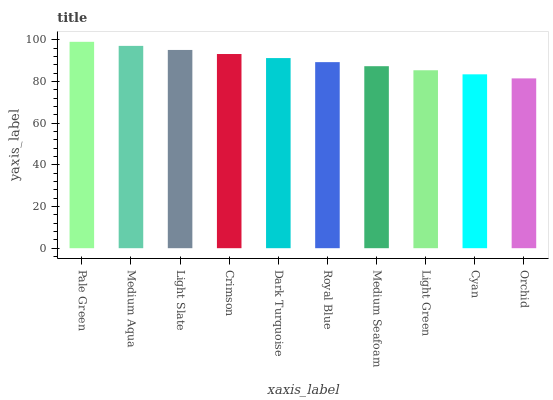Is Orchid the minimum?
Answer yes or no. Yes. Is Pale Green the maximum?
Answer yes or no. Yes. Is Medium Aqua the minimum?
Answer yes or no. No. Is Medium Aqua the maximum?
Answer yes or no. No. Is Pale Green greater than Medium Aqua?
Answer yes or no. Yes. Is Medium Aqua less than Pale Green?
Answer yes or no. Yes. Is Medium Aqua greater than Pale Green?
Answer yes or no. No. Is Pale Green less than Medium Aqua?
Answer yes or no. No. Is Dark Turquoise the high median?
Answer yes or no. Yes. Is Royal Blue the low median?
Answer yes or no. Yes. Is Orchid the high median?
Answer yes or no. No. Is Dark Turquoise the low median?
Answer yes or no. No. 